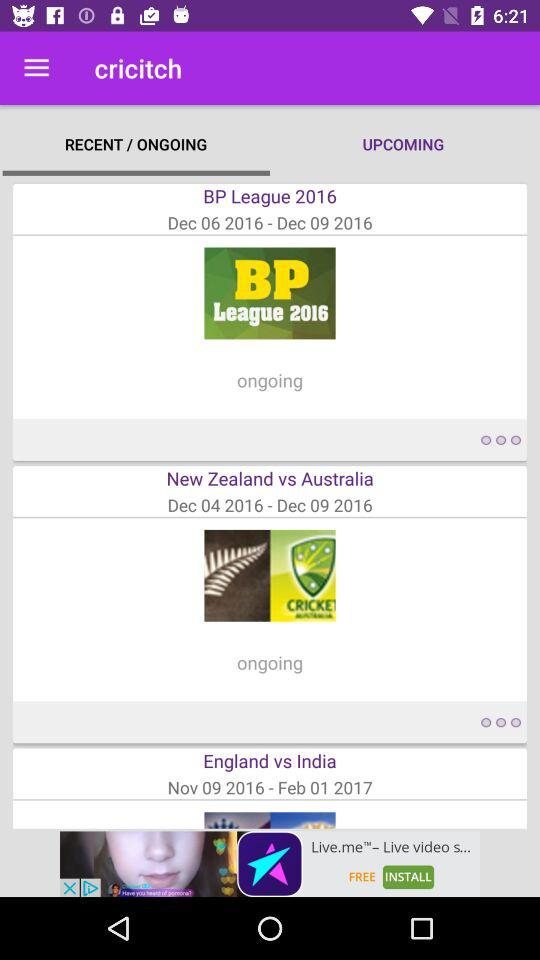What is the start date of the "New Zealand" vs. "Australia" series? The start date is December 4, 2016. 